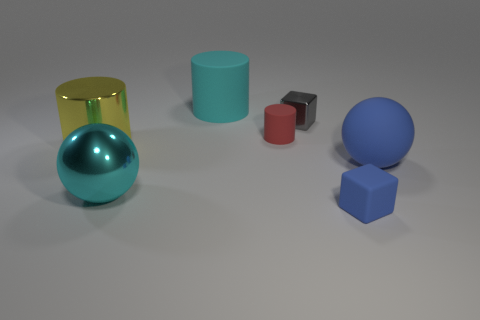Is there a cylinder that has the same color as the tiny rubber cube?
Give a very brief answer. No. Does the small gray shiny object have the same shape as the red rubber object?
Your answer should be very brief. No. How many large things are purple metal things or red matte cylinders?
Your answer should be very brief. 0. There is a large cylinder that is made of the same material as the tiny gray thing; what color is it?
Make the answer very short. Yellow. How many large yellow objects have the same material as the small red cylinder?
Your answer should be compact. 0. There is a shiny thing to the right of the small cylinder; does it have the same size as the blue matte object in front of the metallic ball?
Your answer should be very brief. Yes. The cube that is in front of the cylinder that is left of the big cyan rubber cylinder is made of what material?
Provide a short and direct response. Rubber. Are there fewer big matte balls that are on the right side of the big metal cylinder than red things that are to the right of the red cylinder?
Your answer should be very brief. No. What material is the big cylinder that is the same color as the large metal sphere?
Ensure brevity in your answer.  Rubber. Is there any other thing that has the same shape as the tiny red matte thing?
Provide a short and direct response. Yes. 